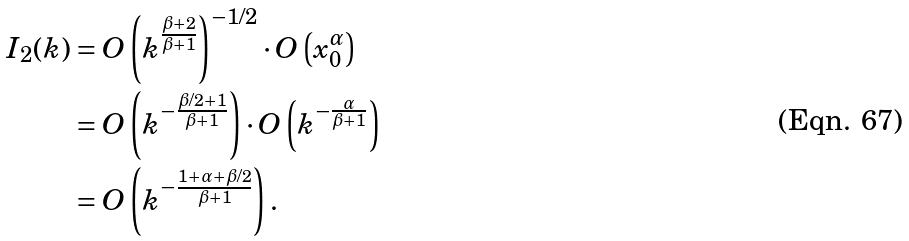Convert formula to latex. <formula><loc_0><loc_0><loc_500><loc_500>I _ { 2 } ( k ) & = O \left ( k ^ { \frac { \beta + 2 } { \beta + 1 } } \right ) ^ { - 1 / 2 } \cdot O \left ( x _ { 0 } ^ { \alpha } \right ) \\ & = O \left ( k ^ { - \frac { \beta / 2 + 1 } { \beta + 1 } } \right ) \cdot O \left ( k ^ { - \frac { \alpha } { \beta + 1 } } \right ) \\ & = O \left ( k ^ { - \frac { 1 + \alpha + \beta / 2 } { \beta + 1 } } \right ) .</formula> 